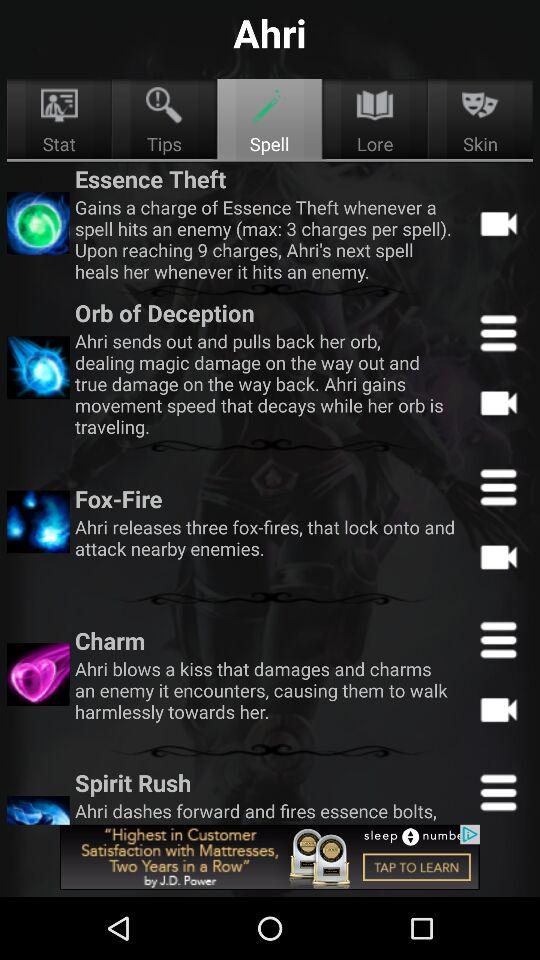What is the name of the application? The name of the application is "Ahri". 